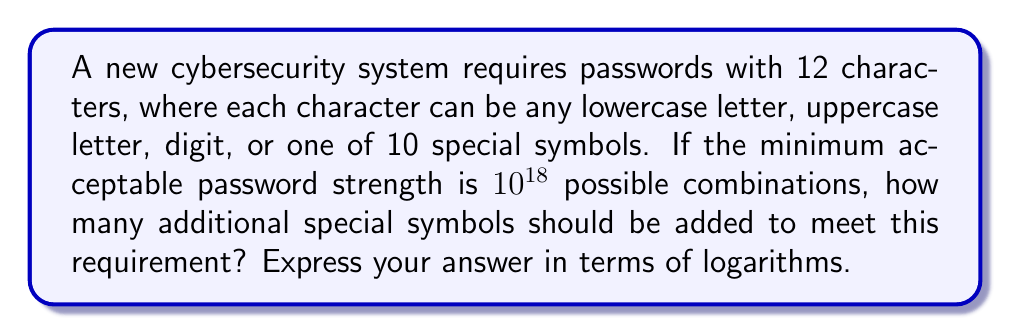Teach me how to tackle this problem. Let's approach this step-by-step:

1) First, let's calculate the current number of possible characters:
   - 26 lowercase letters
   - 26 uppercase letters
   - 10 digits
   - 10 special symbols
   Total: $26 + 26 + 10 + 10 = 72$ characters

2) With 12 character positions, the current number of combinations is:
   $72^{12}$

3) We need this to be at least $10^{18}$. Let's express this as an inequality:
   $72^{12} \cdot (72+x)^{12} \geq 10^{18}$
   where $x$ is the number of additional special symbols.

4) Taking the logarithm of both sides (base 10):
   $\log(72^{12}) + \log((72+x)^{12}) \geq 18$

5) Using the logarithm property $\log(a^n) = n\log(a)$:
   $12\log(72) + 12\log(72+x) \geq 18$

6) Simplify:
   $12\log(72+x) \geq 18 - 12\log(72)$

7) Divide both sides by 12:
   $\log(72+x) \geq \frac{18}{12} - \log(72)$

8) Use the inverse logarithm (antilog) on both sides:
   $72+x \geq 10^{\frac{18}{12} - \log(72)}$

9) Subtract 72 from both sides:
   $x \geq 10^{\frac{18}{12} - \log(72)} - 72$

Therefore, the number of additional special symbols needed is the ceiling of this value.
Answer: $\lceil 10^{\frac{3}{2} - \log(72)} - 72 \rceil$ 